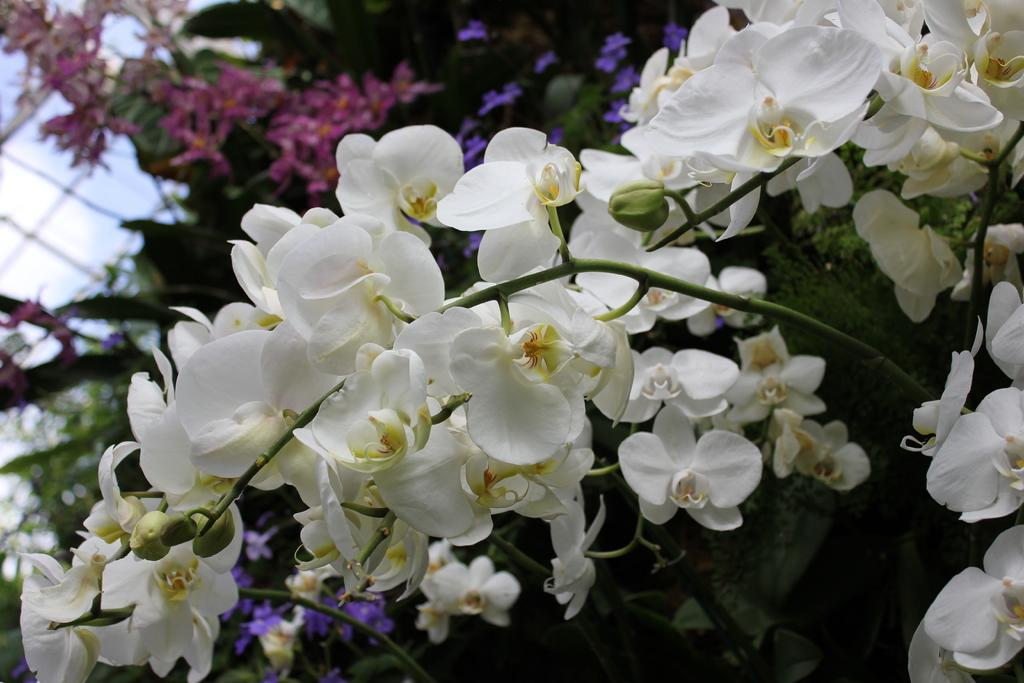What type of flowers can be seen in the image? There are white color flowers in the image. Are there any flowers that are not fully bloomed in the image? Yes, there are flower buds in the image. Where are the flowers located in relation to other objects? The flowers are near steps. Can you describe the flowers visible in the background of the image? There are more flowers visible in the background of the image, but their color and type cannot be determined from the provided facts. What time of day is it in the image, and how does the crow contribute to the morning atmosphere? There is no crow present in the image, and the time of day cannot be determined from the provided facts. 